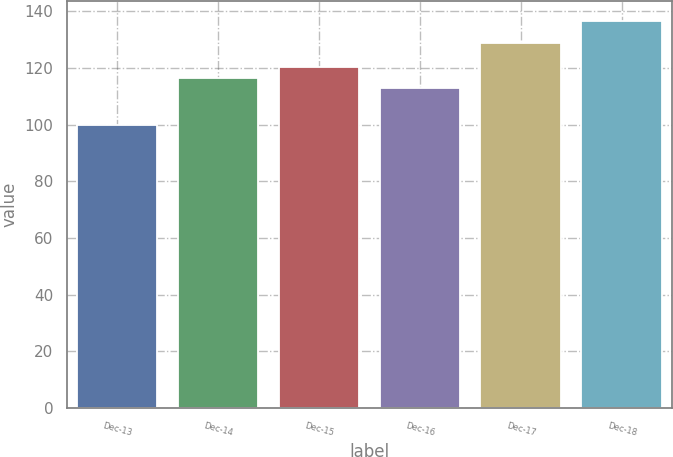<chart> <loc_0><loc_0><loc_500><loc_500><bar_chart><fcel>Dec-13<fcel>Dec-14<fcel>Dec-15<fcel>Dec-16<fcel>Dec-17<fcel>Dec-18<nl><fcel>100<fcel>116.46<fcel>120.12<fcel>112.8<fcel>128.9<fcel>136.56<nl></chart> 